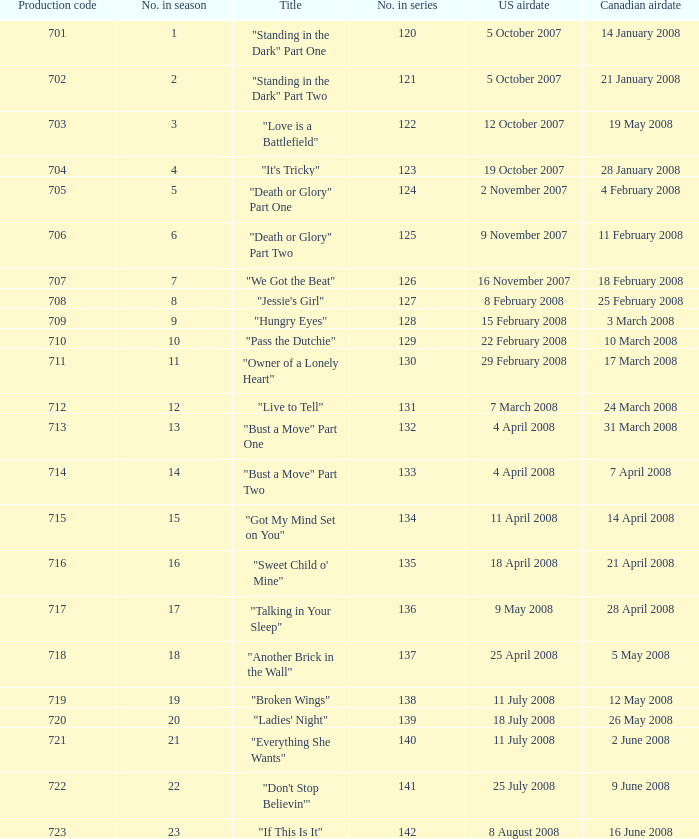For the episode(s) aired in the U.S. on 4 april 2008, what were the names? "Bust a Move" Part One, "Bust a Move" Part Two. 